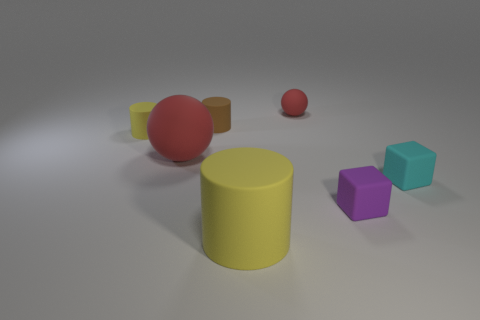What shape is the cyan rubber thing?
Provide a succinct answer. Cube. What material is the tiny object that is both behind the small yellow cylinder and on the right side of the large yellow cylinder?
Make the answer very short. Rubber. What is the shape of the big yellow object that is made of the same material as the small sphere?
Your response must be concise. Cylinder. What size is the cyan object that is the same material as the large yellow object?
Make the answer very short. Small. There is a object that is behind the large matte sphere and to the left of the small brown cylinder; what is its shape?
Offer a terse response. Cylinder. How big is the yellow cylinder behind the yellow cylinder in front of the tiny purple matte object?
Give a very brief answer. Small. How many other objects are there of the same color as the big rubber cylinder?
Your answer should be compact. 1. What is the tiny brown cylinder made of?
Offer a very short reply. Rubber. Are there any tiny purple matte cubes?
Keep it short and to the point. Yes. Are there an equal number of cylinders right of the small cyan rubber cube and big spheres?
Keep it short and to the point. No. 